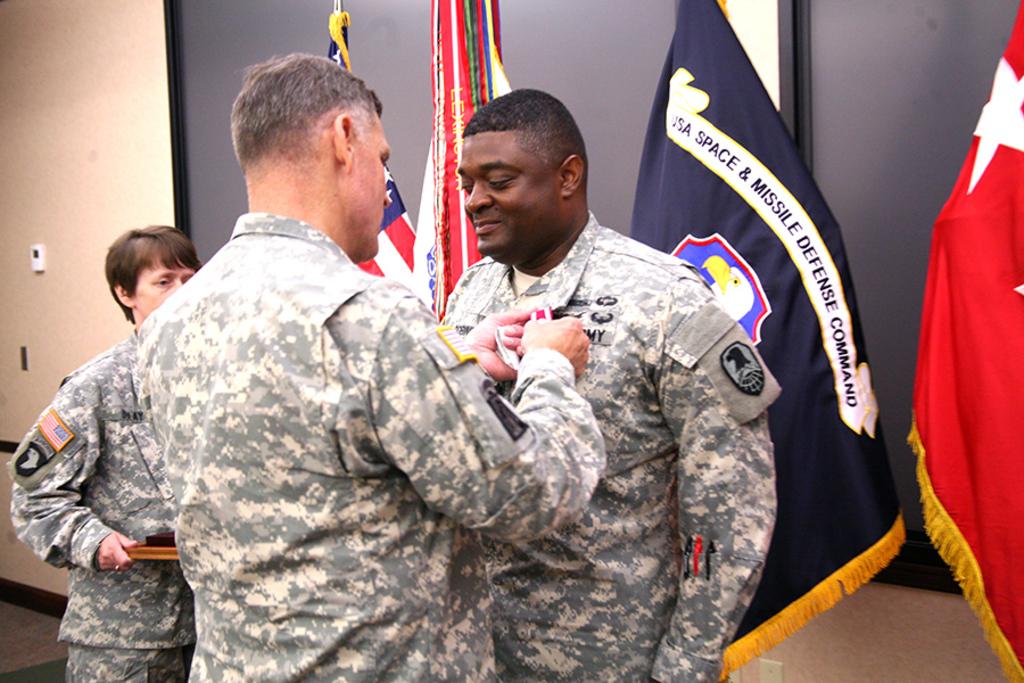In which branch of the military do these fine people serve?
Ensure brevity in your answer.  Army. Which command is on the flag?
Offer a terse response. Usa space and missile defense command. 